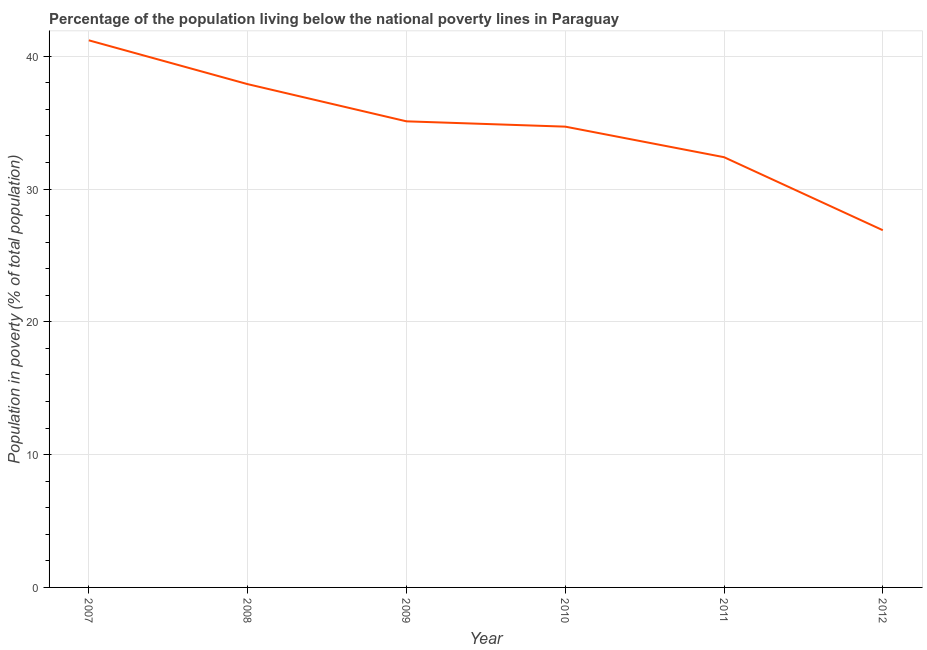What is the percentage of population living below poverty line in 2011?
Make the answer very short. 32.4. Across all years, what is the maximum percentage of population living below poverty line?
Ensure brevity in your answer.  41.2. Across all years, what is the minimum percentage of population living below poverty line?
Offer a terse response. 26.9. In which year was the percentage of population living below poverty line maximum?
Provide a succinct answer. 2007. What is the sum of the percentage of population living below poverty line?
Ensure brevity in your answer.  208.2. What is the difference between the percentage of population living below poverty line in 2008 and 2010?
Your answer should be compact. 3.2. What is the average percentage of population living below poverty line per year?
Ensure brevity in your answer.  34.7. What is the median percentage of population living below poverty line?
Your answer should be very brief. 34.9. In how many years, is the percentage of population living below poverty line greater than 22 %?
Make the answer very short. 6. What is the ratio of the percentage of population living below poverty line in 2007 to that in 2009?
Provide a succinct answer. 1.17. Is the percentage of population living below poverty line in 2010 less than that in 2012?
Make the answer very short. No. What is the difference between the highest and the second highest percentage of population living below poverty line?
Offer a terse response. 3.3. Is the sum of the percentage of population living below poverty line in 2007 and 2010 greater than the maximum percentage of population living below poverty line across all years?
Offer a very short reply. Yes. What is the difference between the highest and the lowest percentage of population living below poverty line?
Offer a terse response. 14.3. Does the percentage of population living below poverty line monotonically increase over the years?
Your response must be concise. No. How many lines are there?
Your answer should be compact. 1. Are the values on the major ticks of Y-axis written in scientific E-notation?
Provide a succinct answer. No. What is the title of the graph?
Provide a succinct answer. Percentage of the population living below the national poverty lines in Paraguay. What is the label or title of the X-axis?
Provide a short and direct response. Year. What is the label or title of the Y-axis?
Give a very brief answer. Population in poverty (% of total population). What is the Population in poverty (% of total population) in 2007?
Provide a short and direct response. 41.2. What is the Population in poverty (% of total population) of 2008?
Your response must be concise. 37.9. What is the Population in poverty (% of total population) of 2009?
Your answer should be compact. 35.1. What is the Population in poverty (% of total population) of 2010?
Provide a succinct answer. 34.7. What is the Population in poverty (% of total population) of 2011?
Give a very brief answer. 32.4. What is the Population in poverty (% of total population) in 2012?
Give a very brief answer. 26.9. What is the difference between the Population in poverty (% of total population) in 2007 and 2008?
Your response must be concise. 3.3. What is the difference between the Population in poverty (% of total population) in 2007 and 2011?
Your answer should be very brief. 8.8. What is the difference between the Population in poverty (% of total population) in 2009 and 2012?
Provide a succinct answer. 8.2. What is the difference between the Population in poverty (% of total population) in 2010 and 2011?
Make the answer very short. 2.3. What is the ratio of the Population in poverty (% of total population) in 2007 to that in 2008?
Provide a short and direct response. 1.09. What is the ratio of the Population in poverty (% of total population) in 2007 to that in 2009?
Offer a very short reply. 1.17. What is the ratio of the Population in poverty (% of total population) in 2007 to that in 2010?
Your answer should be compact. 1.19. What is the ratio of the Population in poverty (% of total population) in 2007 to that in 2011?
Ensure brevity in your answer.  1.27. What is the ratio of the Population in poverty (% of total population) in 2007 to that in 2012?
Offer a terse response. 1.53. What is the ratio of the Population in poverty (% of total population) in 2008 to that in 2010?
Your response must be concise. 1.09. What is the ratio of the Population in poverty (% of total population) in 2008 to that in 2011?
Ensure brevity in your answer.  1.17. What is the ratio of the Population in poverty (% of total population) in 2008 to that in 2012?
Your answer should be very brief. 1.41. What is the ratio of the Population in poverty (% of total population) in 2009 to that in 2011?
Give a very brief answer. 1.08. What is the ratio of the Population in poverty (% of total population) in 2009 to that in 2012?
Offer a terse response. 1.3. What is the ratio of the Population in poverty (% of total population) in 2010 to that in 2011?
Provide a succinct answer. 1.07. What is the ratio of the Population in poverty (% of total population) in 2010 to that in 2012?
Keep it short and to the point. 1.29. What is the ratio of the Population in poverty (% of total population) in 2011 to that in 2012?
Give a very brief answer. 1.2. 